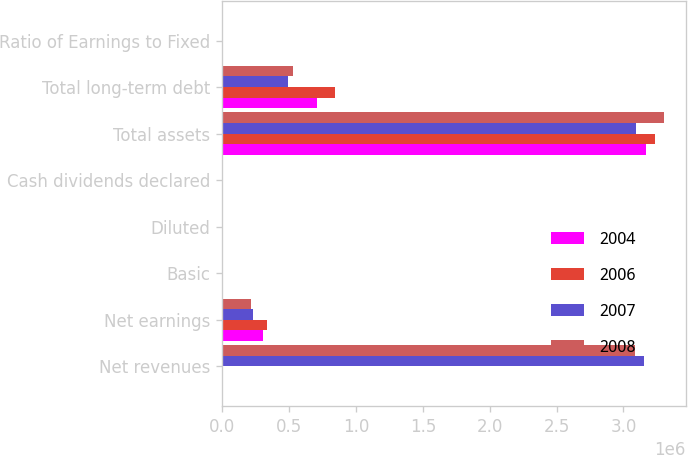Convert chart. <chart><loc_0><loc_0><loc_500><loc_500><stacked_bar_chart><ecel><fcel>Net revenues<fcel>Net earnings<fcel>Basic<fcel>Diluted<fcel>Cash dividends declared<fcel>Total assets<fcel>Total long-term debt<fcel>Ratio of Earnings to Fixed<nl><fcel>2004<fcel>10.3<fcel>306766<fcel>2.18<fcel>2<fcel>0.8<fcel>3.1688e+06<fcel>709723<fcel>8.15<nl><fcel>2006<fcel>10.3<fcel>333003<fcel>2.13<fcel>1.97<fcel>0.64<fcel>3.23706e+06<fcel>845071<fcel>10.86<nl><fcel>2007<fcel>3.15148e+06<fcel>230055<fcel>1.38<fcel>1.29<fcel>0.48<fcel>3.0969e+06<fcel>494917<fcel>9.74<nl><fcel>2008<fcel>3.08763e+06<fcel>212075<fcel>1.19<fcel>1.09<fcel>0.36<fcel>3.30114e+06<fcel>528389<fcel>8.33<nl></chart> 